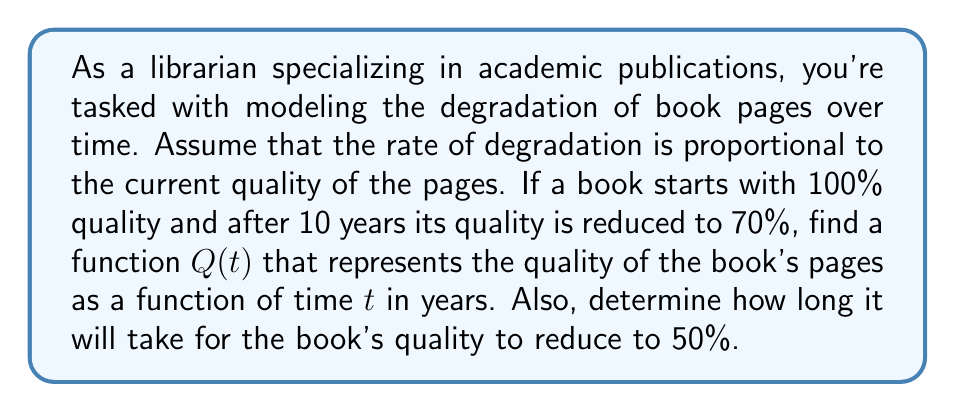Can you answer this question? Let's approach this step-by-step:

1) Let $Q(t)$ represent the quality of the book's pages at time $t$. The rate of change of quality with respect to time is proportional to the current quality:

   $$\frac{dQ}{dt} = -kQ$$

   where $k$ is a positive constant representing the degradation rate.

2) This is a separable first-order differential equation. We can solve it as follows:

   $$\frac{dQ}{Q} = -k dt$$

3) Integrating both sides:

   $$\int \frac{dQ}{Q} = -\int k dt$$

   $$\ln|Q| = -kt + C$$

4) Solving for $Q$:

   $$Q(t) = Ae^{-kt}$$

   where $A = e^C$ is a constant.

5) We know that at $t=0$, $Q(0) = 100\%$, so:

   $$100 = Ae^{-k(0)} = A$$

6) Now we can write our general solution:

   $$Q(t) = 100e^{-kt}$$

7) We're also given that after 10 years, the quality is 70%. Let's use this to find $k$:

   $$70 = 100e^{-k(10)}$$
   $$0.7 = e^{-10k}$$
   $$\ln(0.7) = -10k$$
   $$k = -\frac{\ln(0.7)}{10} \approx 0.0357$$

8) Now we have our complete function:

   $$Q(t) = 100e^{-0.0357t}$$

9) To find when the quality will be 50%, we solve:

   $$50 = 100e^{-0.0357t}$$
   $$0.5 = e^{-0.0357t}$$
   $$\ln(0.5) = -0.0357t$$
   $$t = -\frac{\ln(0.5)}{0.0357} \approx 19.4$$
Answer: The function representing the quality of the book's pages over time is:

$$Q(t) = 100e^{-0.0357t}$$

where $t$ is time in years.

It will take approximately 19.4 years for the book's quality to reduce to 50%. 